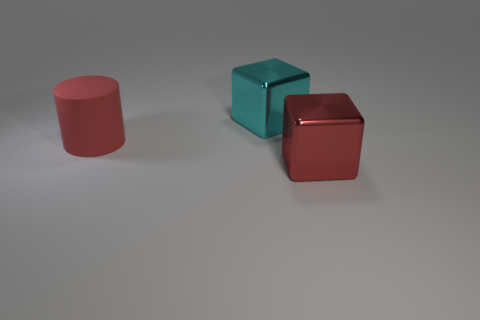Subtract all gray cylinders. Subtract all yellow spheres. How many cylinders are left? 1 Add 3 big red things. How many objects exist? 6 Subtract all cylinders. How many objects are left? 2 Subtract 0 brown spheres. How many objects are left? 3 Subtract all large red rubber things. Subtract all big red things. How many objects are left? 0 Add 1 red metal things. How many red metal things are left? 2 Add 2 large red rubber objects. How many large red rubber objects exist? 3 